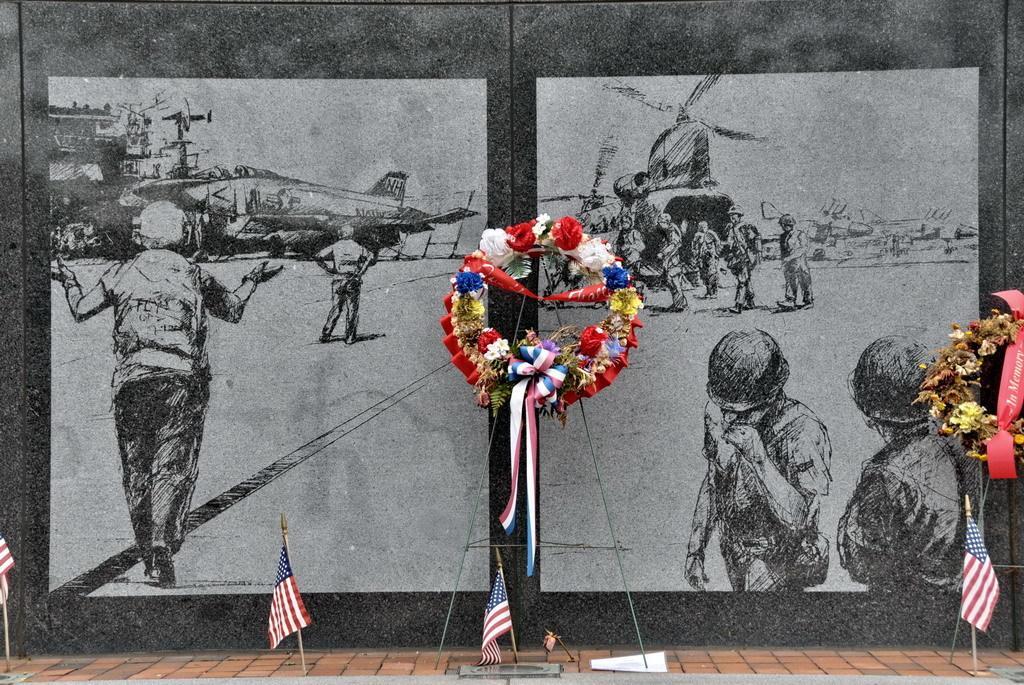What type of vehicle is depicted in the drawings in the image? There are drawings of a helicopter in the image. Who or what else is depicted in the drawings in the image? There are drawings of persons in the image. What is the background of the drawings in the image? There is a depiction of the sky in the image. What is located at the bottom of the image? Flags are present at the bottom of the image. What is the central feature of the image? There is a garland in the center of the image. What type of beast is tied up with a knot in the image? There is no beast or knot present in the image. Can you describe the yak in the image? There is no yak present in the image. 